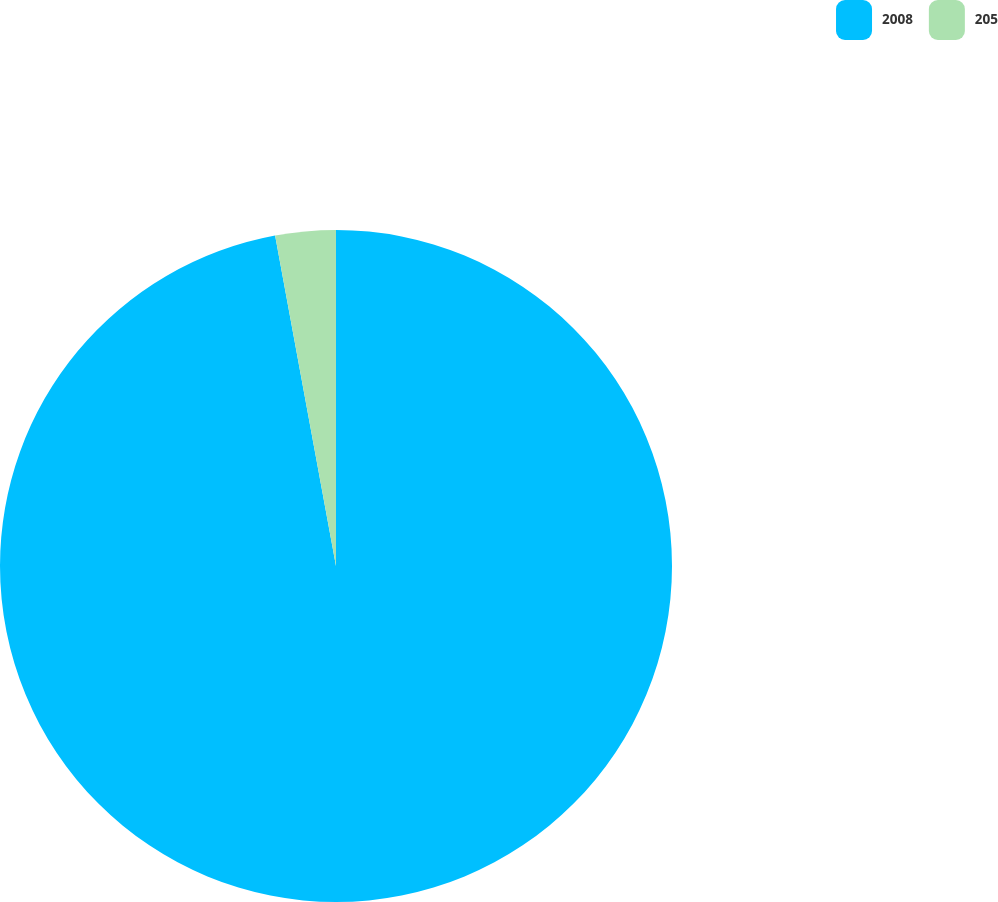Convert chart. <chart><loc_0><loc_0><loc_500><loc_500><pie_chart><fcel>2008<fcel>205<nl><fcel>97.1%<fcel>2.9%<nl></chart> 